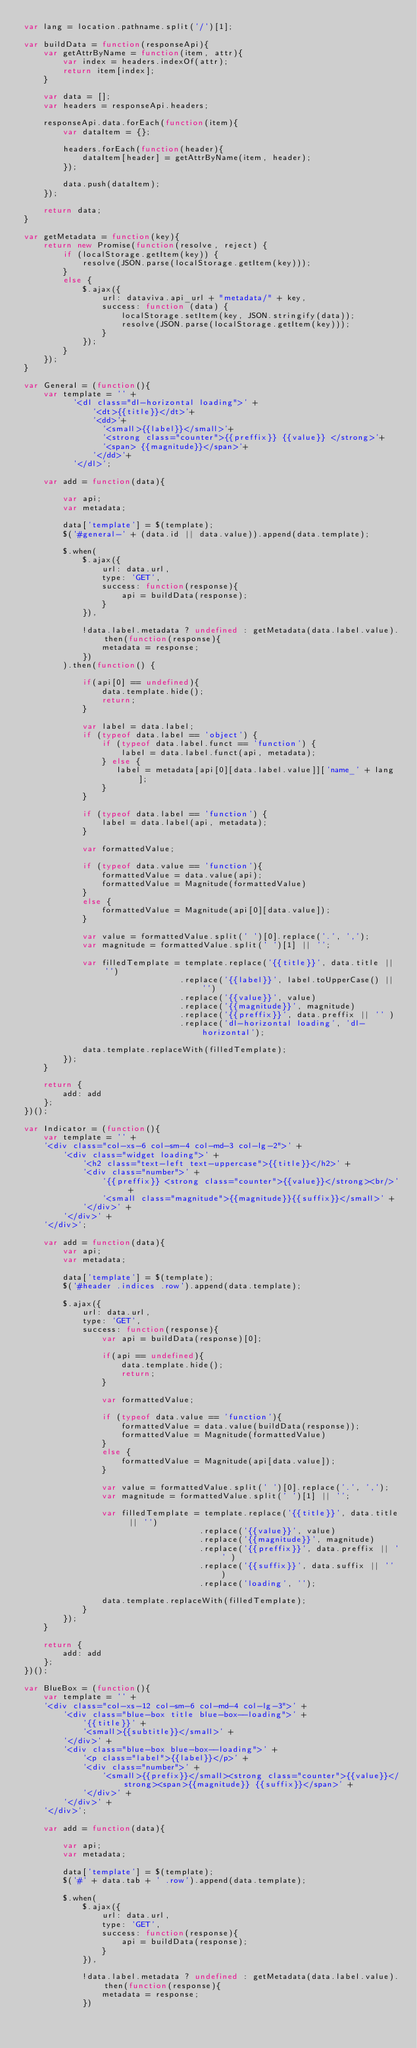<code> <loc_0><loc_0><loc_500><loc_500><_JavaScript_>var lang = location.pathname.split('/')[1];

var buildData = function(responseApi){
    var getAttrByName = function(item, attr){
        var index = headers.indexOf(attr);
        return item[index];
    }

    var data = [];
    var headers = responseApi.headers;

    responseApi.data.forEach(function(item){
        var dataItem = {};

        headers.forEach(function(header){
            dataItem[header] = getAttrByName(item, header);
        });

        data.push(dataItem);
    });

    return data;
}

var getMetadata = function(key){
    return new Promise(function(resolve, reject) {
        if (localStorage.getItem(key)) {
            resolve(JSON.parse(localStorage.getItem(key)));
        }
        else {
            $.ajax({
                url: dataviva.api_url + "metadata/" + key,
                success: function (data) {
                    localStorage.setItem(key, JSON.stringify(data));
                    resolve(JSON.parse(localStorage.getItem(key)));
                }
            });
        }
    });
}

var General = (function(){
    var template = '' +
          '<dl class="dl-horizontal loading">' +
              '<dt>{{title}}</dt>'+
              '<dd>'+
                '<small>{{label}}</small>'+
                '<strong class="counter">{{preffix}} {{value}} </strong>'+
                '<span> {{magnitude}}</span>'+
              '</dd>'+
          '</dl>';

    var add = function(data){

        var api;
        var metadata;

        data['template'] = $(template);
        $('#general-' + (data.id || data.value)).append(data.template);

        $.when(
            $.ajax({
                url: data.url,
                type: 'GET',
                success: function(response){
                    api = buildData(response);
                }
            }),

            !data.label.metadata ? undefined : getMetadata(data.label.value).then(function(response){
                metadata = response;
            })
        ).then(function() {

            if(api[0] == undefined){
                data.template.hide();
                return;
            }

            var label = data.label;
            if (typeof data.label == 'object') {
                if (typeof data.label.funct == 'function') {
                    label = data.label.funct(api, metadata);
                } else {
                   label = metadata[api[0][data.label.value]]['name_' + lang];
                }
            }

            if (typeof data.label == 'function') {
                label = data.label(api, metadata);
            }

            var formattedValue;

            if (typeof data.value == 'function'){
                formattedValue = data.value(api);
                formattedValue = Magnitude(formattedValue)
            }
            else {
                formattedValue = Magnitude(api[0][data.value]);
            }

            var value = formattedValue.split(' ')[0].replace('.', ',');
            var magnitude = formattedValue.split(' ')[1] || '';

            var filledTemplate = template.replace('{{title}}', data.title || '')
                                .replace('{{label}}', label.toUpperCase() || '')
                                .replace('{{value}}', value)
                                .replace('{{magnitude}}', magnitude)
                                .replace('{{preffix}}', data.preffix || '' )
                                .replace('dl-horizontal loading', 'dl-horizontal');

            data.template.replaceWith(filledTemplate);
        });
    }

    return {
        add: add
    };
})();

var Indicator = (function(){
    var template = '' +
    '<div class="col-xs-6 col-sm-4 col-md-3 col-lg-2">' +
        '<div class="widget loading">' +
            '<h2 class="text-left text-uppercase">{{title}}</h2>' +
            '<div class="number">' +
                '{{preffix}} <strong class="counter">{{value}}</strong><br/>' +
                '<small class="magnitude">{{magnitude}}{{suffix}}</small>' +
            '</div>' +
        '</div>' +
    '</div>';
    
    var add = function(data){
        var api;
        var metadata;

        data['template'] = $(template);
        $('#header .indices .row').append(data.template);

        $.ajax({
            url: data.url,
            type: 'GET',
            success: function(response){
                var api = buildData(response)[0];

                if(api == undefined){
                    data.template.hide();
                    return;
                }

                var formattedValue;

                if (typeof data.value == 'function'){
                    formattedValue = data.value(buildData(response));
                    formattedValue = Magnitude(formattedValue)
                }
                else {
                    formattedValue = Magnitude(api[data.value]);
                }

                var value = formattedValue.split(' ')[0].replace('.', ',');
                var magnitude = formattedValue.split(' ')[1] || '';
                
                var filledTemplate = template.replace('{{title}}', data.title || '')
                                    .replace('{{value}}', value)
                                    .replace('{{magnitude}}', magnitude)
                                    .replace('{{preffix}}', data.preffix || '' )
                                    .replace('{{suffix}}', data.suffix || '' )
                                    .replace('loading', '');

                data.template.replaceWith(filledTemplate);
            }
        });
    }

    return {
        add: add
    };
})();

var BlueBox = (function(){
    var template = '' +
    '<div class="col-xs-12 col-sm-6 col-md-4 col-lg-3">' +
        '<div class="blue-box title blue-box--loading">' +
            '{{title}}' +
            '<small>{{subtitle}}</small>' +
        '</div>' +
        '<div class="blue-box blue-box--loading">' +
            '<p class="label">{{label}}</p>' +
            '<div class="number">' +
                '<small>{{prefix}}</small><strong class="counter">{{value}}</strong><span>{{magnitude}} {{suffix}}</span>' +
            '</div>' +
        '</div>' +
    '</div>';

    var add = function(data){

        var api;
        var metadata;

        data['template'] = $(template);
        $('#' + data.tab + ' .row').append(data.template);

        $.when(
            $.ajax({
                url: data.url, 
                type: 'GET',    
                success: function(response){
                    api = buildData(response);
                }           
            }),

            !data.label.metadata ? undefined : getMetadata(data.label.value).then(function(response){
                metadata = response;
            })</code> 